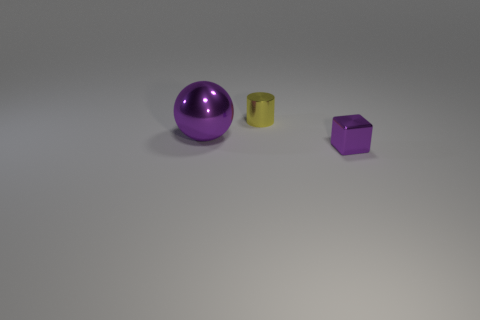What size is the metal sphere that is the same color as the tiny cube?
Offer a very short reply. Large. Is the color of the big ball the same as the metal block?
Ensure brevity in your answer.  Yes. Are there any other things of the same color as the shiny cylinder?
Your answer should be compact. No. What is the material of the tiny thing behind the purple object that is right of the shiny thing on the left side of the small yellow shiny cylinder?
Ensure brevity in your answer.  Metal. How many things are the same size as the ball?
Your answer should be compact. 0. There is a thing that is in front of the yellow metal cylinder and on the right side of the purple ball; what is it made of?
Give a very brief answer. Metal. There is a small yellow shiny thing; how many big metal objects are behind it?
Make the answer very short. 0. Does the large purple thing have the same shape as the tiny thing that is behind the purple cube?
Your answer should be very brief. No. There is a purple shiny object that is in front of the shiny object left of the tiny yellow thing; what shape is it?
Your answer should be very brief. Cube. There is a yellow thing to the left of the small metallic block; what is its shape?
Make the answer very short. Cylinder. 